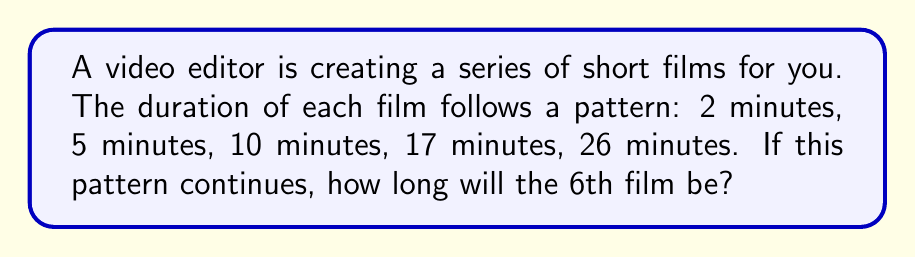Give your solution to this math problem. Let's approach this step-by-step:

1) First, let's look at the differences between consecutive terms:
   $$2 \rightarrow 5 \rightarrow 10 \rightarrow 17 \rightarrow 26$$
   The differences are:
   $$3 \rightarrow 5 \rightarrow 7 \rightarrow 9$$

2) We can see that the differences are increasing by 2 each time:
   $$3 + 2 = 5$$
   $$5 + 2 = 7$$
   $$7 + 2 = 9$$

3) So, the next difference should be:
   $$9 + 2 = 11$$

4) Now, to find the 6th term, we add this difference to the 5th term:
   $$26 + 11 = 37$$

5) We can verify this by looking at the general formula for this sequence:
   The nth term of this sequence can be represented as:
   $$a_n = n^2 - n + 2$$

6) Let's check for n = 6:
   $$a_6 = 6^2 - 6 + 2 = 36 - 6 + 2 = 32 + 2 = 34$$

Therefore, the 6th film in the series will be 37 minutes long.
Answer: 37 minutes 